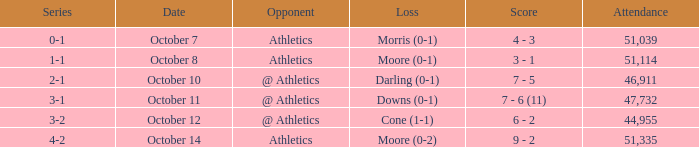When was the game with the loss of Moore (0-1)? October 8. 